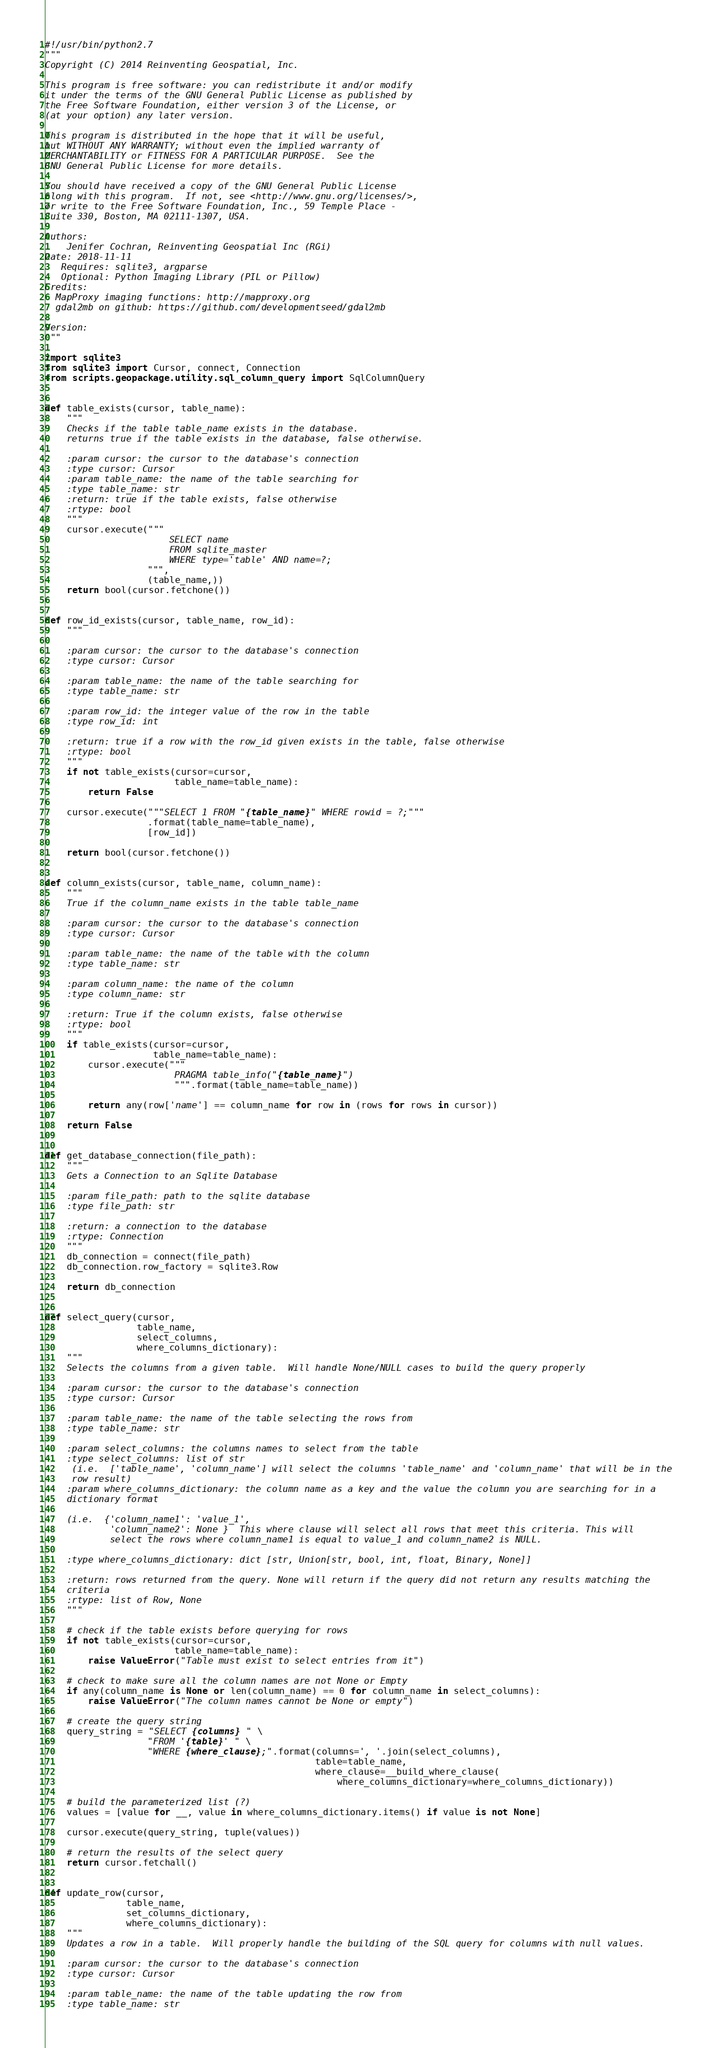<code> <loc_0><loc_0><loc_500><loc_500><_Python_>#!/usr/bin/python2.7
"""
Copyright (C) 2014 Reinventing Geospatial, Inc.

This program is free software: you can redistribute it and/or modify
it under the terms of the GNU General Public License as published by
the Free Software Foundation, either version 3 of the License, or
(at your option) any later version.

This program is distributed in the hope that it will be useful,
but WITHOUT ANY WARRANTY; without even the implied warranty of
MERCHANTABILITY or FITNESS FOR A PARTICULAR PURPOSE.  See the
GNU General Public License for more details.

You should have received a copy of the GNU General Public License
along with this program.  If not, see <http://www.gnu.org/licenses/>,
or write to the Free Software Foundation, Inc., 59 Temple Place -
Suite 330, Boston, MA 02111-1307, USA.

Authors:
    Jenifer Cochran, Reinventing Geospatial Inc (RGi)
Date: 2018-11-11
   Requires: sqlite3, argparse
   Optional: Python Imaging Library (PIL or Pillow)
Credits:
  MapProxy imaging functions: http://mapproxy.org
  gdal2mb on github: https://github.com/developmentseed/gdal2mb

Version:
"""

import sqlite3
from sqlite3 import Cursor, connect, Connection
from scripts.geopackage.utility.sql_column_query import SqlColumnQuery


def table_exists(cursor, table_name):
    """
    Checks if the table table_name exists in the database.
    returns true if the table exists in the database, false otherwise.

    :param cursor: the cursor to the database's connection
    :type cursor: Cursor
    :param table_name: the name of the table searching for
    :type table_name: str
    :return: true if the table exists, false otherwise
    :rtype: bool
    """
    cursor.execute("""
                       SELECT name 
                       FROM sqlite_master 
                       WHERE type='table' AND name=?;
                   """,
                   (table_name,))
    return bool(cursor.fetchone())


def row_id_exists(cursor, table_name, row_id):
    """

    :param cursor: the cursor to the database's connection
    :type cursor: Cursor

    :param table_name: the name of the table searching for
    :type table_name: str

    :param row_id: the integer value of the row in the table
    :type row_id: int

    :return: true if a row with the row_id given exists in the table, false otherwise
    :rtype: bool
    """
    if not table_exists(cursor=cursor,
                        table_name=table_name):
        return False

    cursor.execute("""SELECT 1 FROM "{table_name}" WHERE rowid = ?;"""
                   .format(table_name=table_name),
                   [row_id])

    return bool(cursor.fetchone())


def column_exists(cursor, table_name, column_name):
    """
    True if the column_name exists in the table table_name

    :param cursor: the cursor to the database's connection
    :type cursor: Cursor

    :param table_name: the name of the table with the column
    :type table_name: str

    :param column_name: the name of the column
    :type column_name: str

    :return: True if the column exists, false otherwise
    :rtype: bool
    """
    if table_exists(cursor=cursor,
                    table_name=table_name):
        cursor.execute("""
                        PRAGMA table_info("{table_name}")
                        """.format(table_name=table_name))

        return any(row['name'] == column_name for row in (rows for rows in cursor))

    return False


def get_database_connection(file_path):
    """
    Gets a Connection to an Sqlite Database

    :param file_path: path to the sqlite database
    :type file_path: str

    :return: a connection to the database
    :rtype: Connection
    """
    db_connection = connect(file_path)
    db_connection.row_factory = sqlite3.Row

    return db_connection


def select_query(cursor,
                 table_name,
                 select_columns,
                 where_columns_dictionary):
    """
    Selects the columns from a given table.  Will handle None/NULL cases to build the query properly

    :param cursor: the cursor to the database's connection
    :type cursor: Cursor

    :param table_name: the name of the table selecting the rows from
    :type table_name: str

    :param select_columns: the columns names to select from the table
    :type select_columns: list of str
     (i.e.  ['table_name', 'column_name'] will select the columns 'table_name' and 'column_name' that will be in the
     row result)
    :param where_columns_dictionary: the column name as a key and the value the column you are searching for in a
    dictionary format

    (i.e.  {'column_name1': 'value_1',
            'column_name2': None }  This where clause will select all rows that meet this criteria. This will
            select the rows where column_name1 is equal to value_1 and column_name2 is NULL.

    :type where_columns_dictionary: dict [str, Union[str, bool, int, float, Binary, None]]

    :return: rows returned from the query. None will return if the query did not return any results matching the
    criteria
    :rtype: list of Row, None
    """

    # check if the table exists before querying for rows
    if not table_exists(cursor=cursor,
                        table_name=table_name):
        raise ValueError("Table must exist to select entries from it")

    # check to make sure all the column names are not None or Empty
    if any(column_name is None or len(column_name) == 0 for column_name in select_columns):
        raise ValueError("The column names cannot be None or empty")

    # create the query string
    query_string = "SELECT {columns} " \
                   "FROM '{table}' " \
                   "WHERE {where_clause};".format(columns=', '.join(select_columns),
                                                  table=table_name,
                                                  where_clause=__build_where_clause(
                                                      where_columns_dictionary=where_columns_dictionary))

    # build the parameterized list (?)
    values = [value for __, value in where_columns_dictionary.items() if value is not None]

    cursor.execute(query_string, tuple(values))

    # return the results of the select query
    return cursor.fetchall()


def update_row(cursor,
               table_name,
               set_columns_dictionary,
               where_columns_dictionary):
    """
    Updates a row in a table.  Will properly handle the building of the SQL query for columns with null values.

    :param cursor: the cursor to the database's connection
    :type cursor: Cursor

    :param table_name: the name of the table updating the row from
    :type table_name: str
</code> 